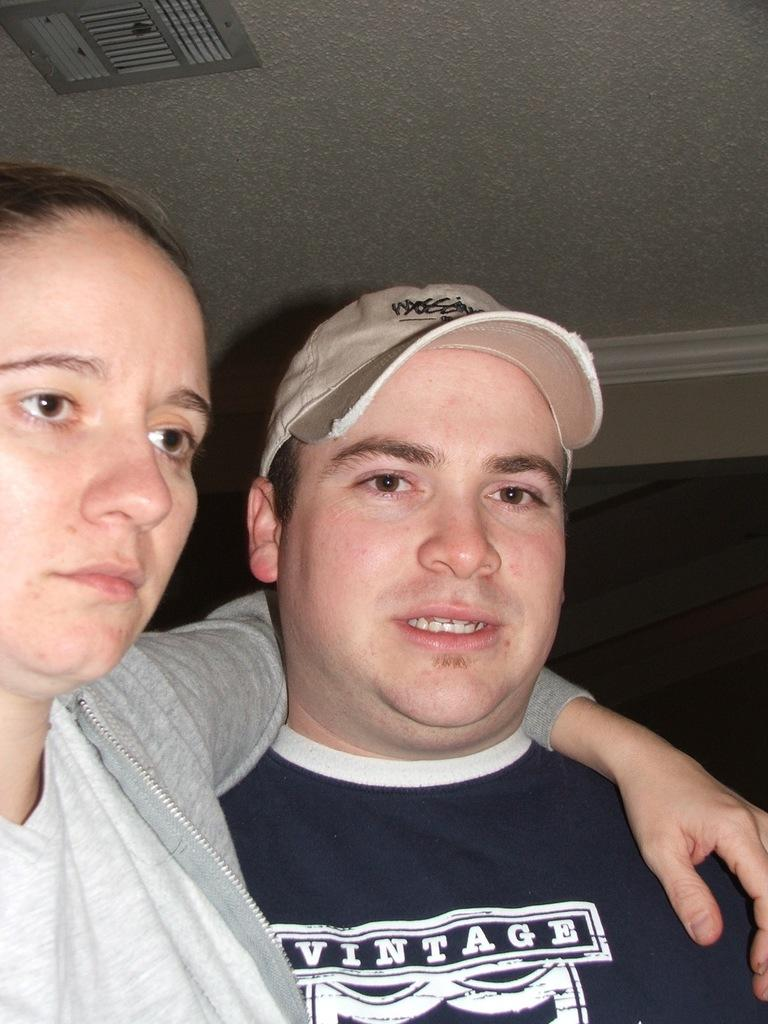Provide a one-sentence caption for the provided image. woman with her arm around man wearing blue vintage shirt. 